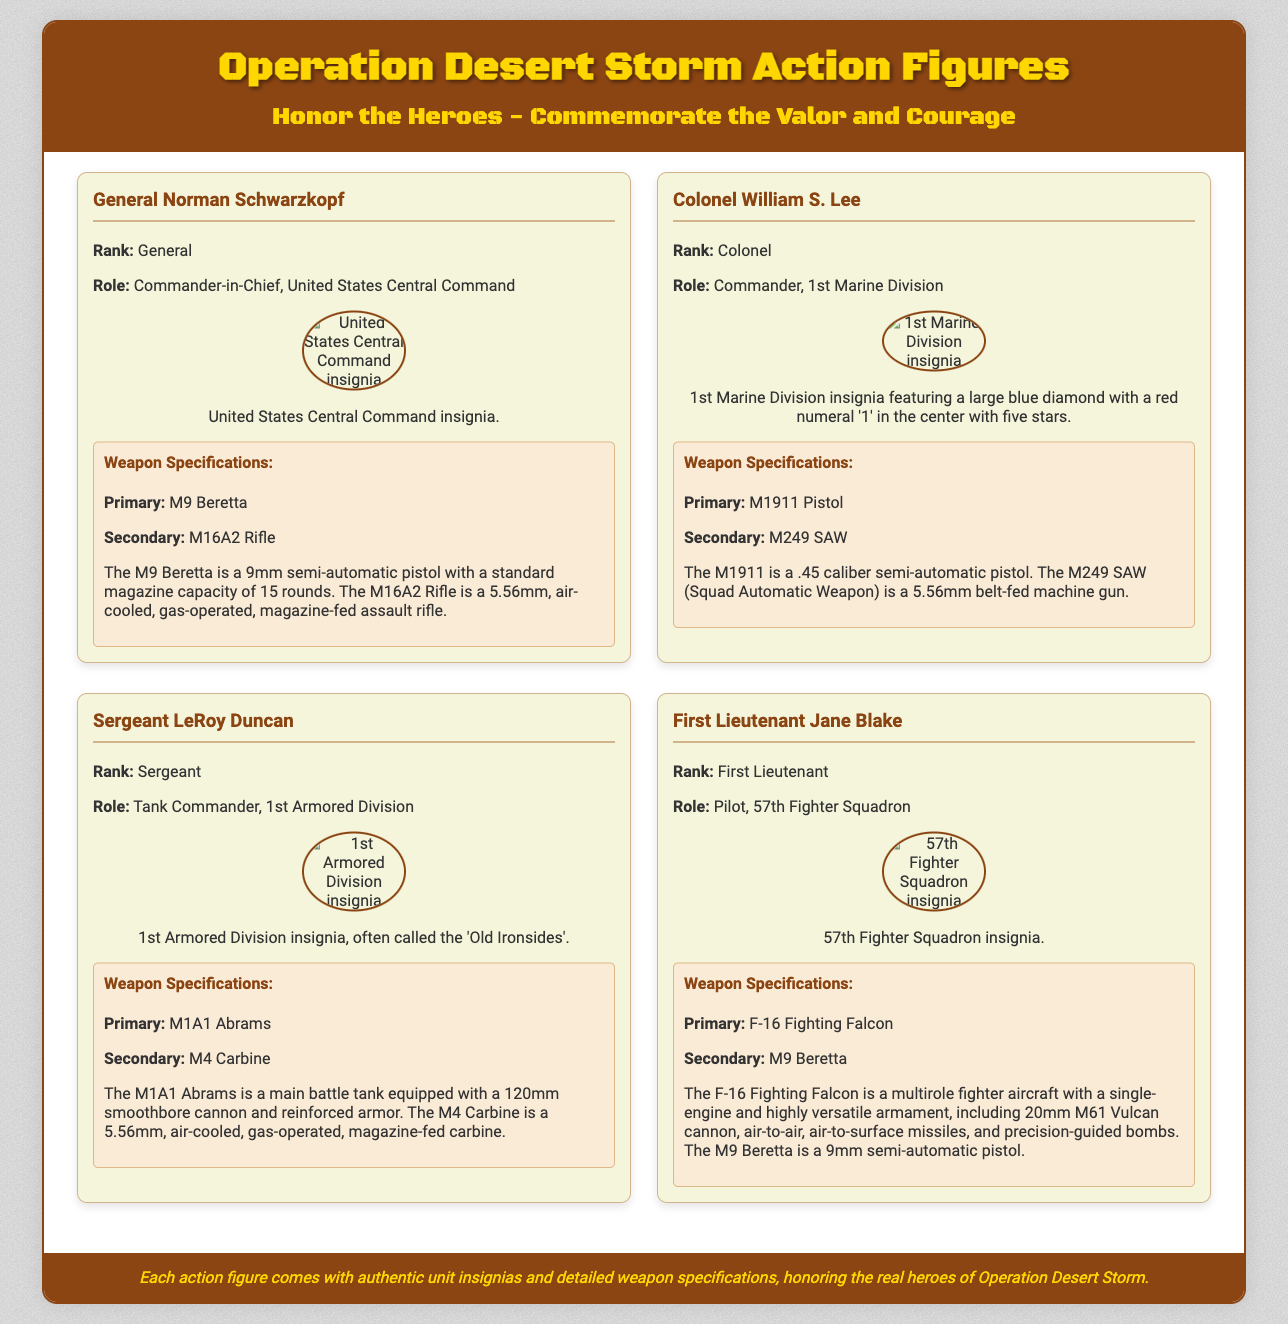What is the rank of General Norman Schwarzkopf? The document states that General Norman Schwarzkopf holds the rank of General.
Answer: General What is the primary weapon of Colonel William S. Lee? According to the document, Colonel William S. Lee's primary weapon is the M1911 Pistol.
Answer: M1911 Pistol What insignia represents the 1st Marine Division? The document describes the 1st Marine Division insignia featuring a large blue diamond with a red numeral '1' and five stars.
Answer: Large blue diamond with a red numeral '1' How many rounds does the M9 Beretta magazine hold? The document mentions that the M9 Beretta has a standard magazine capacity of 15 rounds.
Answer: 15 rounds What is the role of First Lieutenant Jane Blake? Based on the document, First Lieutenant Jane Blake serves as a Pilot in the 57th Fighter Squadron.
Answer: Pilot, 57th Fighter Squadron What type of tank is Sergeant LeRoy Duncan associated with? The document indicates that Sergeant LeRoy Duncan is associated with the M1A1 Abrams tank.
Answer: M1A1 Abrams Which character is the commander of the 1st Armored Division? The document specifies that Sergeant LeRoy Duncan is the tank commander for the 1st Armored Division.
Answer: Sergeant LeRoy Duncan What is the secondary weapon of the General? The document details that the secondary weapon of General Norman Schwarzkopf is the M16A2 Rifle.
Answer: M16A2 Rifle 